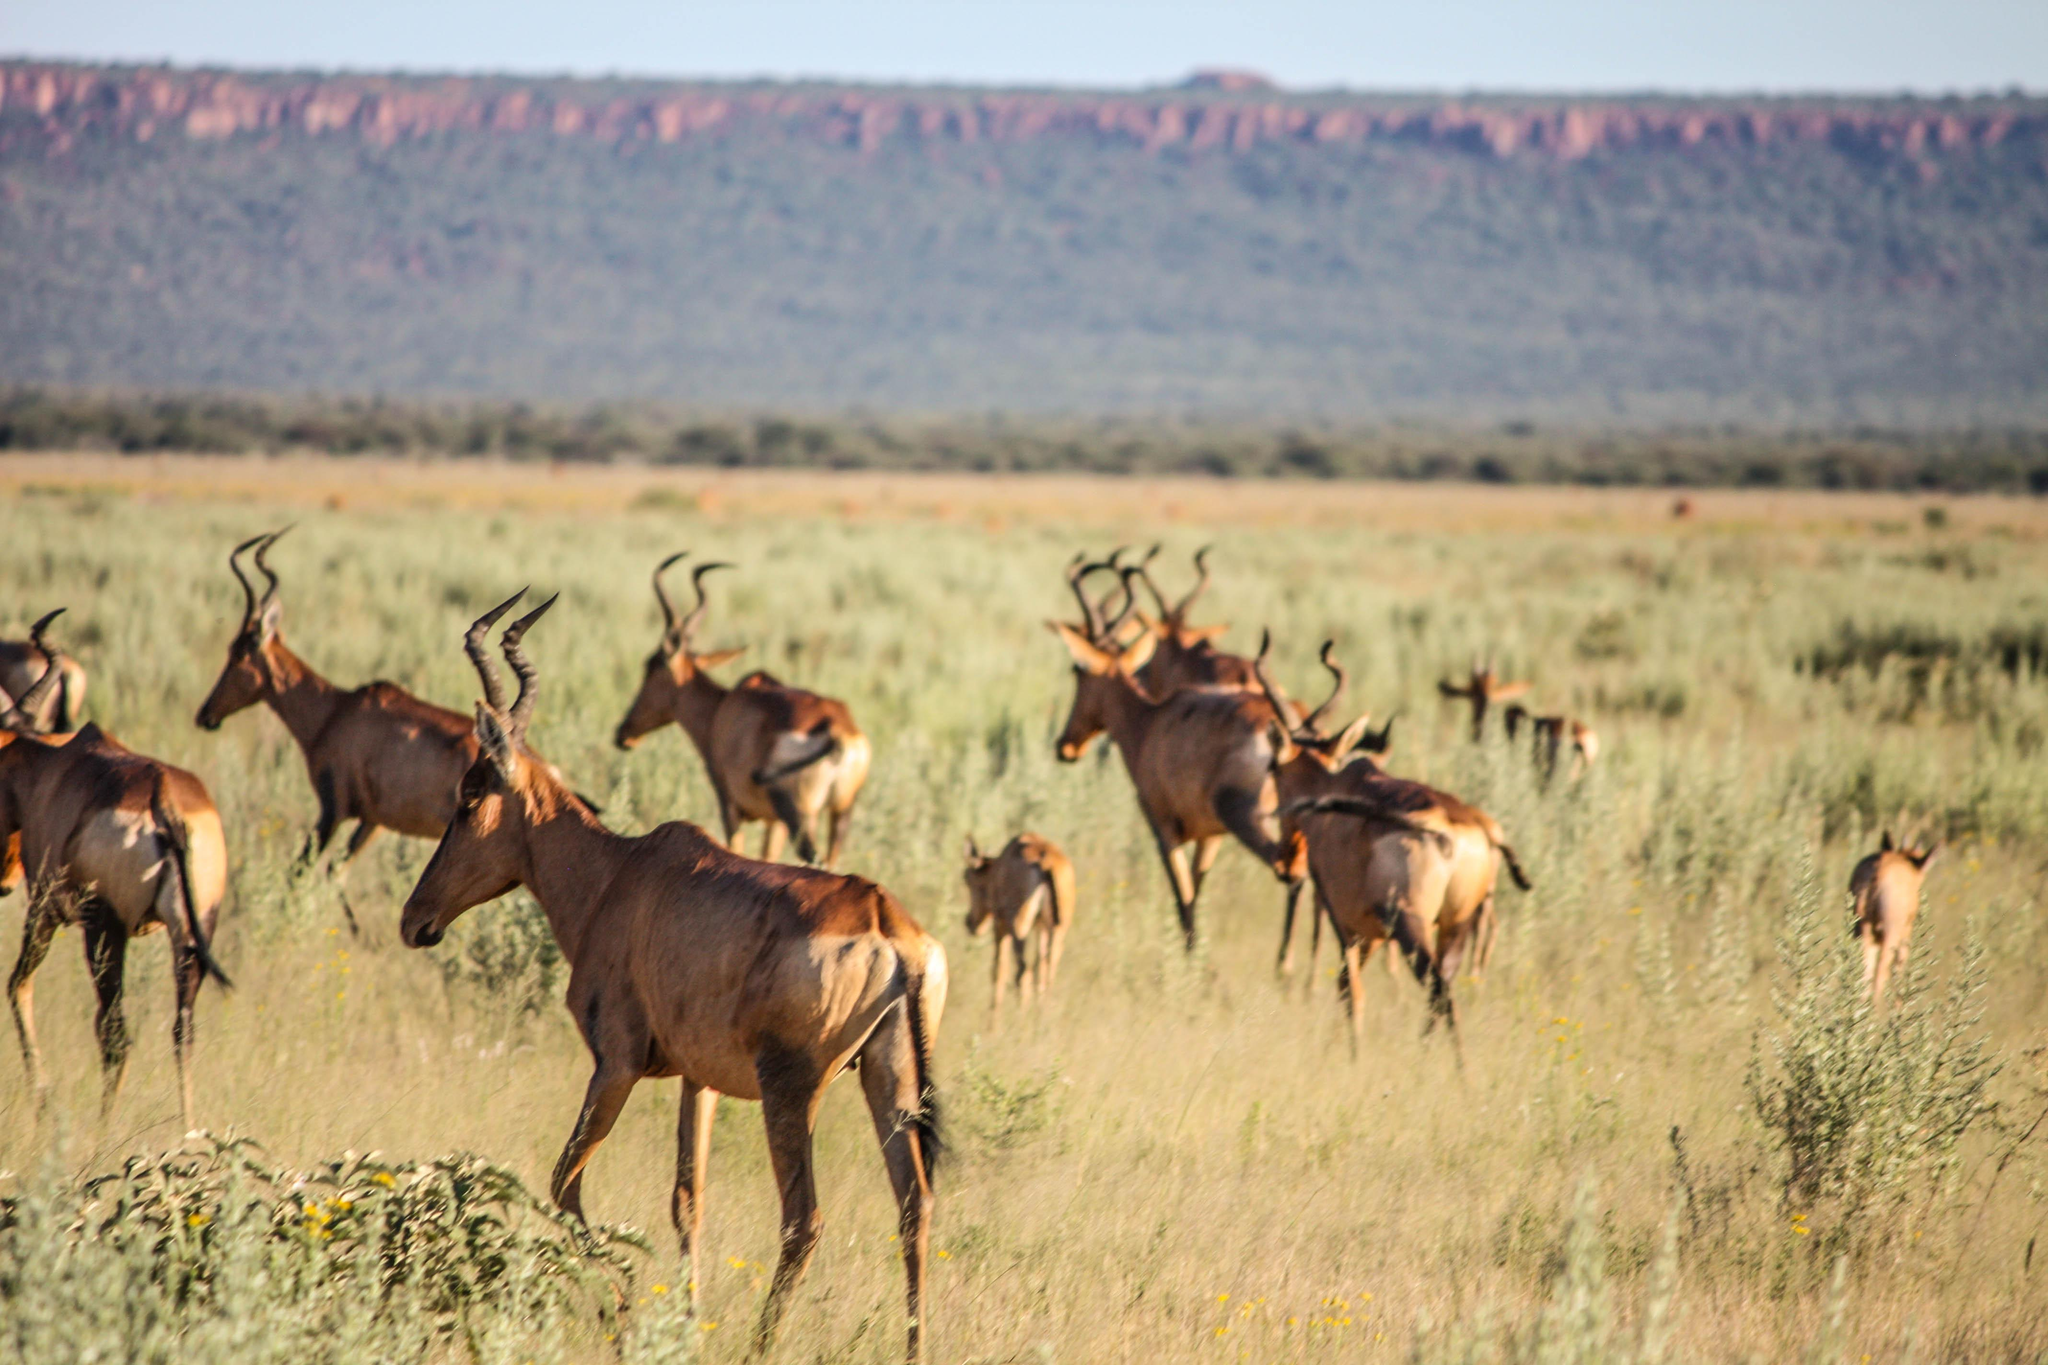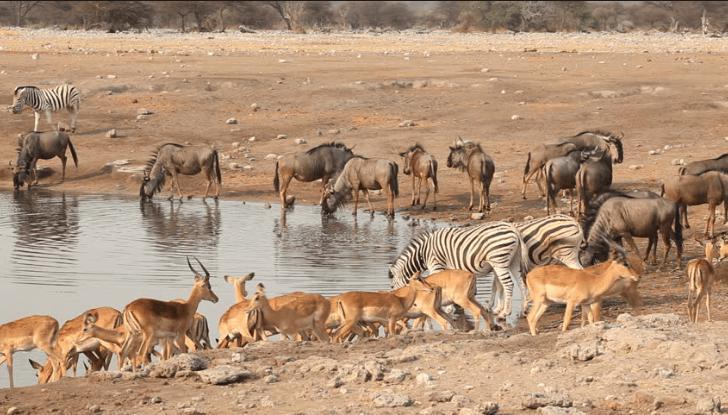The first image is the image on the left, the second image is the image on the right. Considering the images on both sides, is "Zebras and antelopes are mingling together." valid? Answer yes or no. Yes. The first image is the image on the left, the second image is the image on the right. Analyze the images presented: Is the assertion "There are a number of zebras among the other types of animals present." valid? Answer yes or no. Yes. 